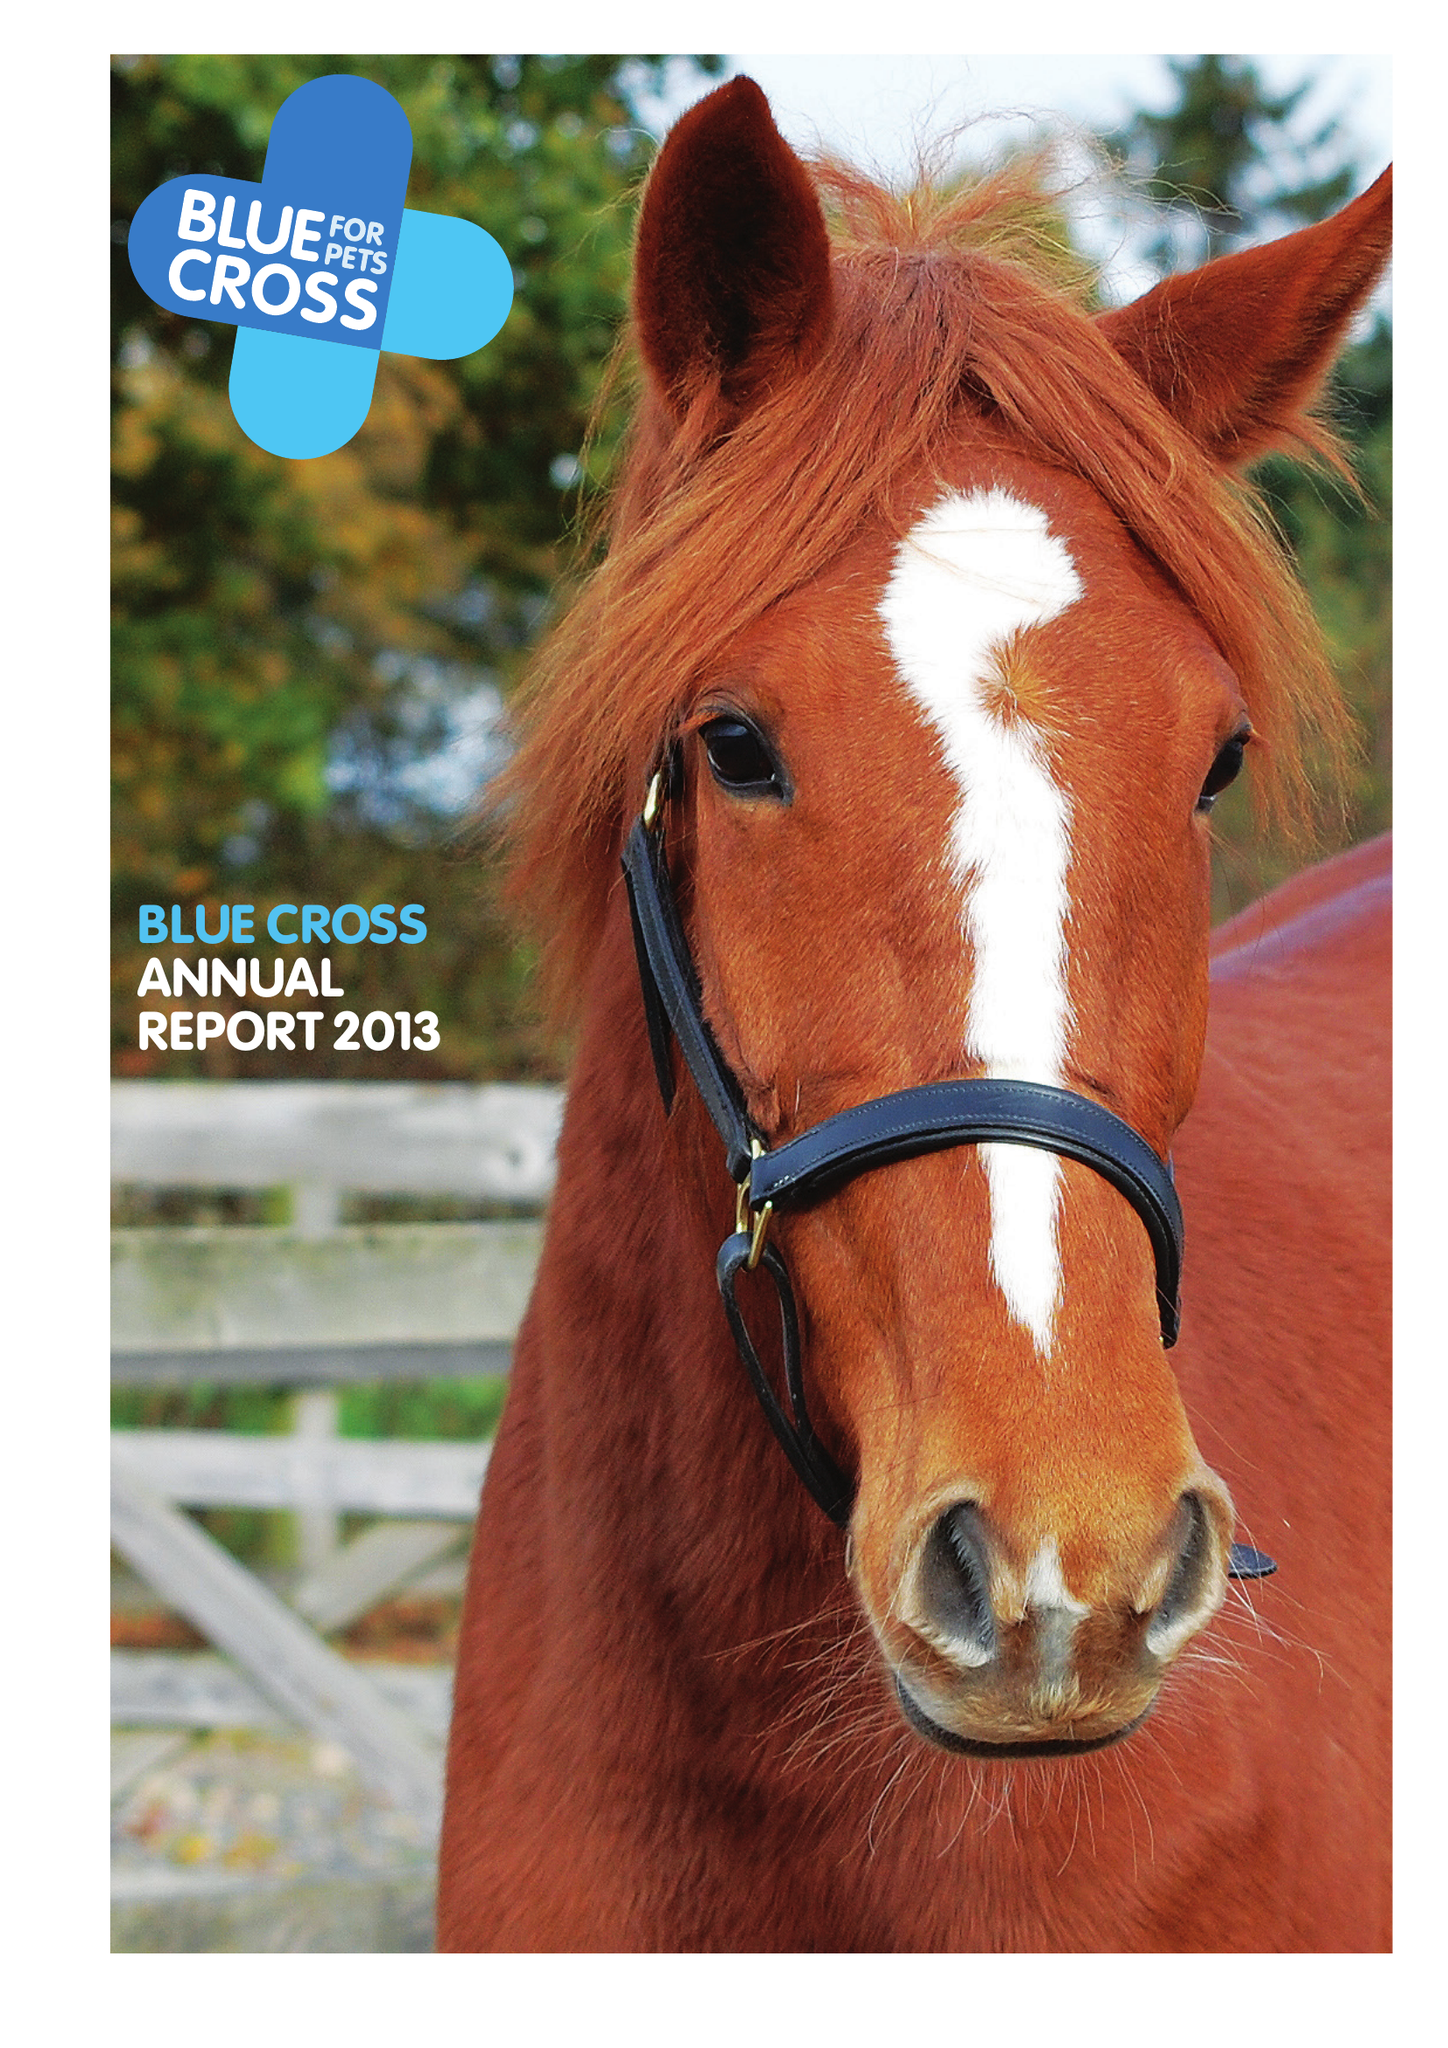What is the value for the income_annually_in_british_pounds?
Answer the question using a single word or phrase. 29493000.00 